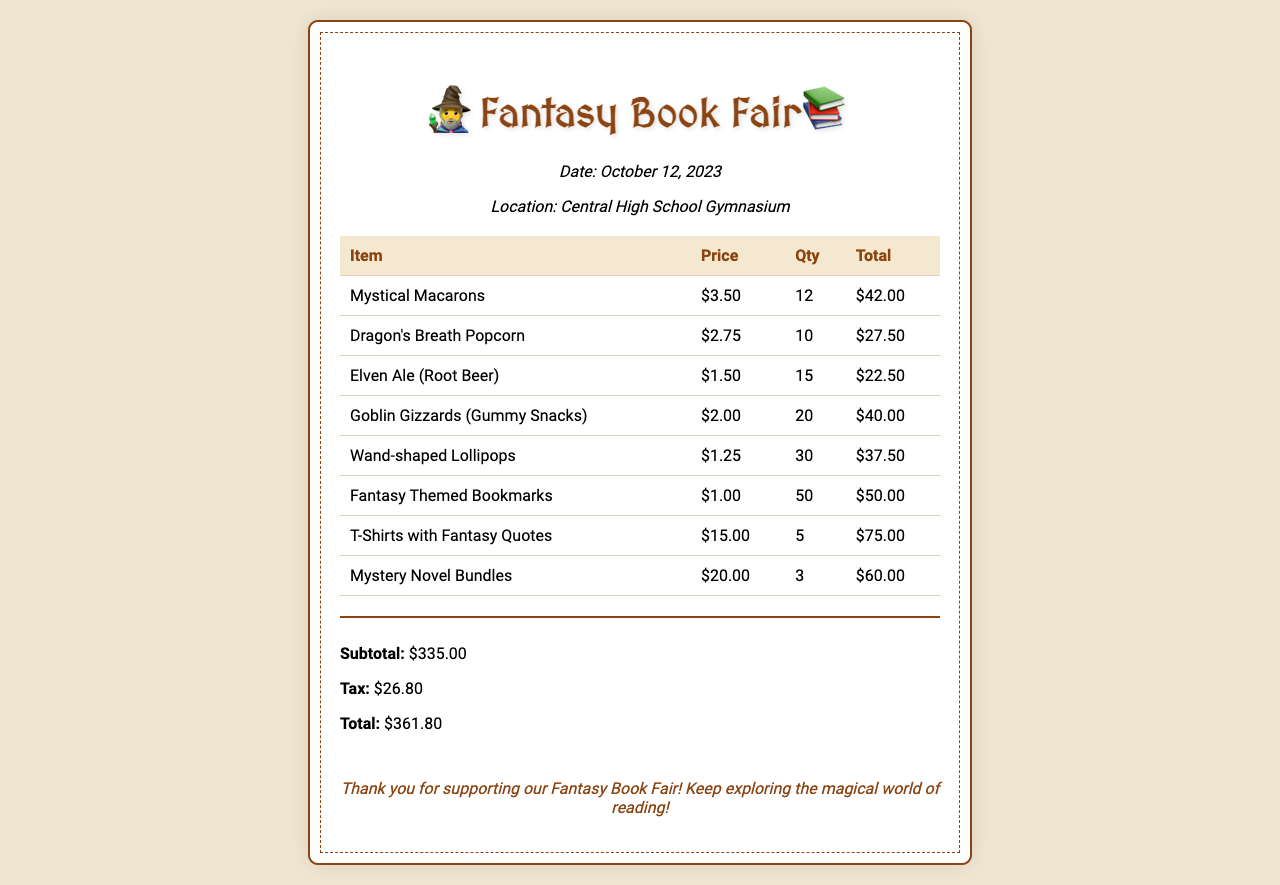What is the date of the event? The event date is specified in the event info section of the receipt.
Answer: October 12, 2023 How many Dragon's Breath Popcorn were sold? The quantity sold is shown in the item row for Dragon's Breath Popcorn, indicating the total number sold.
Answer: 10 What is the price of Wand-shaped Lollipops? The price for Wand-shaped Lollipops is indicated in the corresponding item row.
Answer: $1.25 What is the subtotal amount? The subtotal is the sum of all item totals before tax, displayed in the total section at the bottom of the receipt.
Answer: $335.00 Which drink is sold at $1.50? The document lists drinks with their prices; the one priced at $1.50 can be found easily.
Answer: Elven Ale (Root Beer) How much did the T-Shirts with Fantasy Quotes total? The total for T-Shirts is shown in the item row, calculated based on price and quantity.
Answer: $75.00 What is the total amount due? The total due is displayed under the total section of the receipt, reflecting all charges including tax.
Answer: $361.80 How many Fantasy Themed Bookmarks were sold? This information is captured in the respective item row, showing the quantity sold.
Answer: 50 What type of merchandise is included in the document? The document lists various types of merchandise at the event, focusing on fantasy themes.
Answer: T-Shirts with Fantasy Quotes, Mystery Novel Bundles, Fantasy Themed Bookmarks 